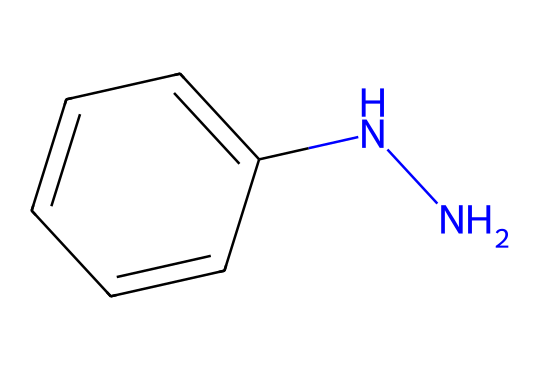What is the total number of atoms in phenylhydrazine? The structure contains 9 atoms: 6 carbons from the phenyl group, 4 hydrogens from the phenyl group, and 2 nitrogens from the hydrazine component. Therefore, 6 (C) + 4 (H) + 2 (N) = 12 atoms in total.
Answer: 12 How many carbon atoms are present in phenylhydrazine? Observing the chemical structure, there are 6 carbon atoms in the phenyl ring connected to the nitrogen atoms.
Answer: 6 What type of bond connects the nitrogen atoms in phenylhydrazine? The nitrogen atoms are connected by a single covalent bond, which is evident in the structure.
Answer: single bond Which functional group is present in phenylhydrazine? The structure contains the hydrazine functional group, specifically represented by the NN fragment.
Answer: hydrazine How does the presence of the phenyl group influence the stability of phenylhydrazine? The phenyl group adds resonance stability to the molecule, allowing for delocalization of electrons, which increases stability.
Answer: resonance stability Is phenylhydrazine an aromatic compound? The phenyl group in the structure provides aromaticity due to its cyclic and planar structure with resonance.
Answer: yes What is the hybridization state of the nitrogen atoms in phenylhydrazine? The nitrogen atoms are typically sp2 hybridized in this compound, consistent with their bonding and geometry in the context of the phenyl ring and the hydrazine moiety.
Answer: sp2 